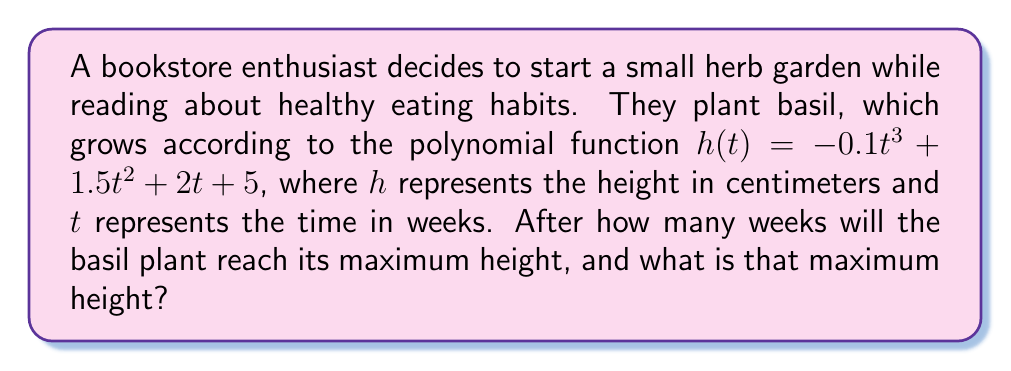Help me with this question. To find the maximum height of the basil plant, we need to follow these steps:

1. Find the derivative of the height function:
   $h'(t) = -0.3t^2 + 3t + 2$

2. Set the derivative equal to zero to find critical points:
   $-0.3t^2 + 3t + 2 = 0$

3. Solve the quadratic equation:
   $t = \frac{-3 \pm \sqrt{3^2 - 4(-0.3)(2)}}{2(-0.3)}$
   $t = \frac{-3 \pm \sqrt{17}}{-0.6}$

4. Calculate the two solutions:
   $t_1 \approx 7.86$ weeks
   $t_2 \approx -0.53$ weeks (discard as time cannot be negative)

5. Verify it's a maximum by checking the second derivative:
   $h''(t) = -0.6t + 3$
   $h''(7.86) \approx -1.72 < 0$, confirming it's a maximum

6. Calculate the maximum height by plugging $t = 7.86$ into the original function:
   $h(7.86) = -0.1(7.86)^3 + 1.5(7.86)^2 + 2(7.86) + 5$
   $h(7.86) \approx 39.69$ cm

Therefore, the basil plant will reach its maximum height after approximately 7.86 weeks, and the maximum height will be about 39.69 cm.
Answer: 7.86 weeks; 39.69 cm 